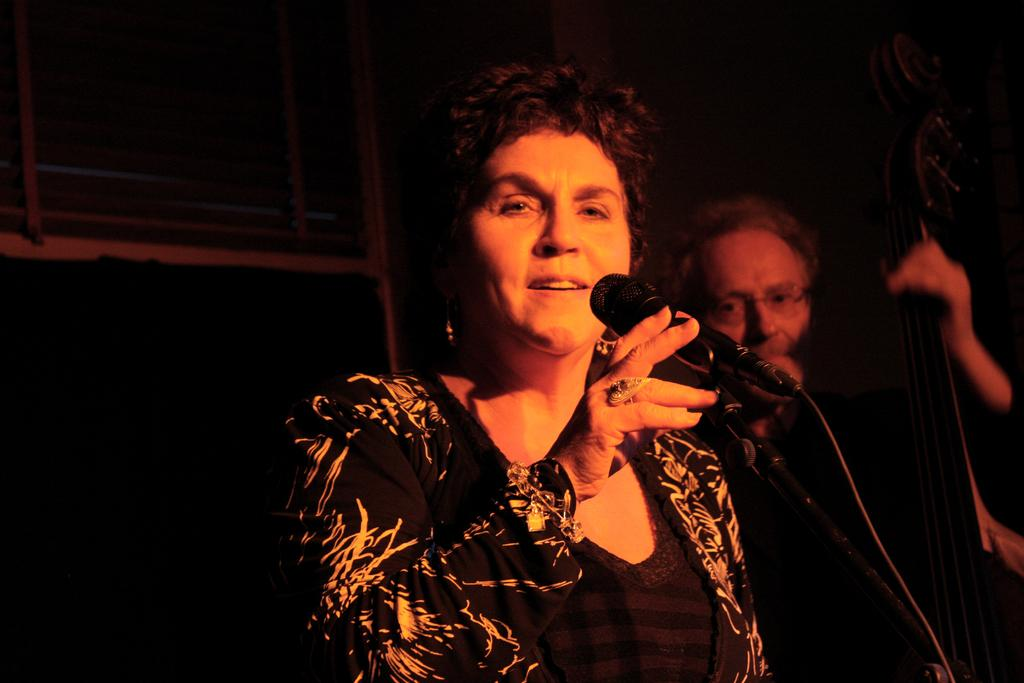What is the color of the background in the image? The background of the image is dark. Can you describe the woman in the image? The woman is holding a microphone in her hand and is smiling. What is the man in the image doing? The man is holding a musical instrument in his hand and is wearing spectacles. What type of fuel is the woman using to power her microphone in the image? There is no indication in the image that the woman's microphone requires fuel, and therefore no such information can be provided. How does the man grip the musical instrument in the image? The image does not show the man's grip on the musical instrument, so it cannot be determined from the image. 